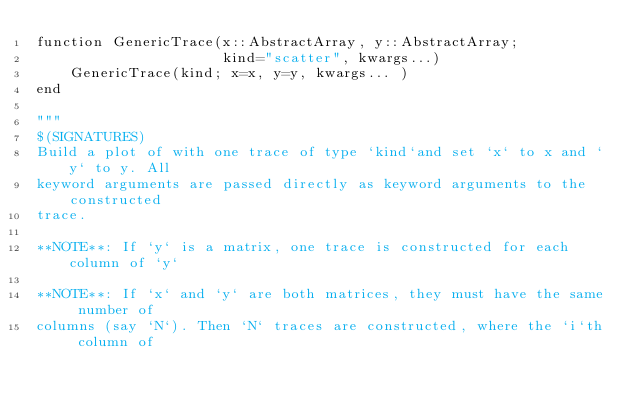Convert code to text. <code><loc_0><loc_0><loc_500><loc_500><_Julia_>function GenericTrace(x::AbstractArray, y::AbstractArray;
                      kind="scatter", kwargs...)
    GenericTrace(kind; x=x, y=y, kwargs... )
end

"""
$(SIGNATURES)
Build a plot of with one trace of type `kind`and set `x` to x and `y` to y. All
keyword arguments are passed directly as keyword arguments to the constructed
trace.

**NOTE**: If `y` is a matrix, one trace is constructed for each column of `y`

**NOTE**: If `x` and `y` are both matrices, they must have the same number of
columns (say `N`). Then `N` traces are constructed, where the `i`th column of</code> 